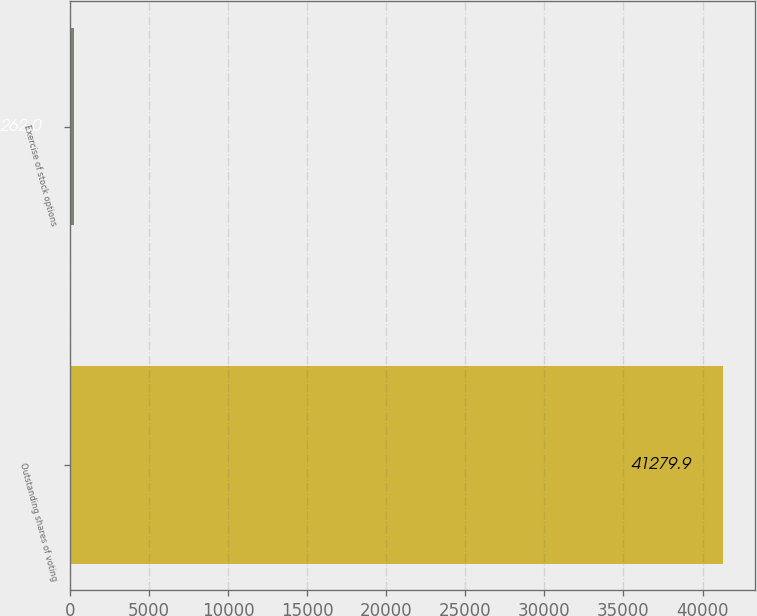Convert chart to OTSL. <chart><loc_0><loc_0><loc_500><loc_500><bar_chart><fcel>Outstanding shares of voting<fcel>Exercise of stock options<nl><fcel>41279.9<fcel>262<nl></chart> 